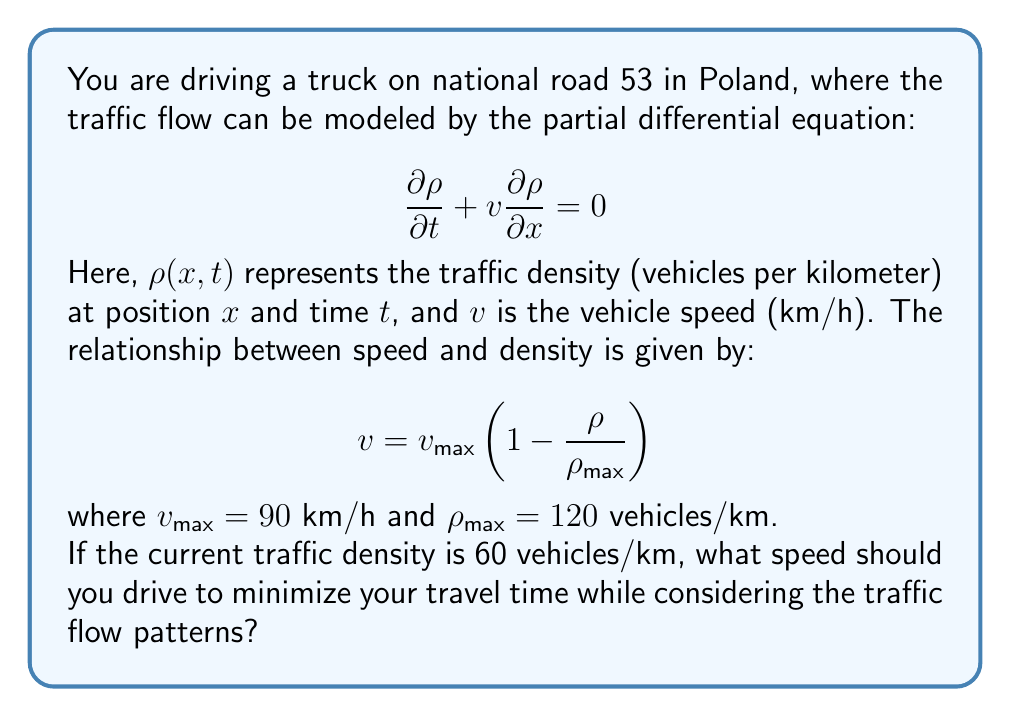Solve this math problem. To solve this problem, we need to find the speed that maximizes the traffic flow, which in turn minimizes travel time. The traffic flow rate $q$ (vehicles per hour) is given by the product of density and speed:

$$q = \rho v$$

Substituting the given speed-density relationship:

$$q = \rho v_{\text{max}}\left(1 - \frac{\rho}{\rho_{\text{max}}}\right)$$

To find the maximum flow rate, we differentiate $q$ with respect to $\rho$ and set it to zero:

$$\frac{dq}{d\rho} = v_{\text{max}}\left(1 - \frac{2\rho}{\rho_{\text{max}}}\right) = 0$$

Solving this equation:

$$1 - \frac{2\rho}{\rho_{\text{max}}} = 0$$
$$\frac{2\rho}{\rho_{\text{max}}} = 1$$
$$\rho = \frac{\rho_{\text{max}}}{2} = \frac{120}{2} = 60 \text{ vehicles/km}$$

This means that the maximum flow rate occurs when the density is half the maximum density, which coincidentally is the current traffic density given in the problem.

Now, we can calculate the optimal speed by substituting this density into the speed-density relationship:

$$v = v_{\text{max}}\left(1 - \frac{\rho}{\rho_{\text{max}}}\right)$$
$$v = 90\left(1 - \frac{60}{120}\right)$$
$$v = 90\left(\frac{1}{2}\right)$$
$$v = 45 \text{ km/h}$$

Therefore, to minimize travel time while considering the traffic flow patterns, you should drive at 45 km/h.
Answer: 45 km/h 